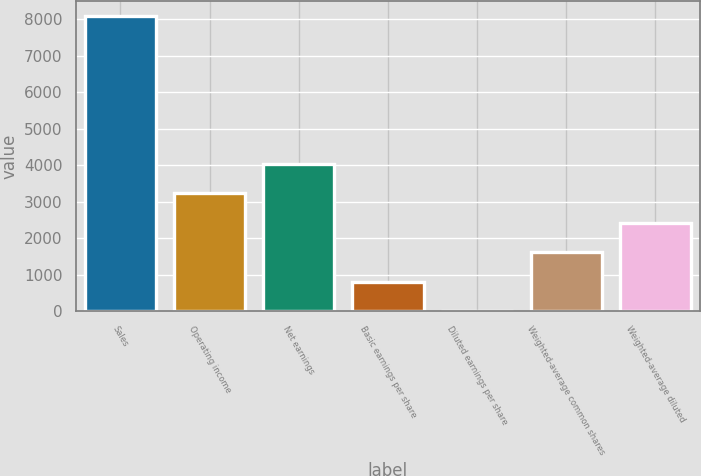Convert chart. <chart><loc_0><loc_0><loc_500><loc_500><bar_chart><fcel>Sales<fcel>Operating income<fcel>Net earnings<fcel>Basic earnings per share<fcel>Diluted earnings per share<fcel>Weighted-average common shares<fcel>Weighted-average diluted<nl><fcel>8085<fcel>3238.27<fcel>4046.06<fcel>814.9<fcel>7.11<fcel>1622.69<fcel>2430.48<nl></chart> 